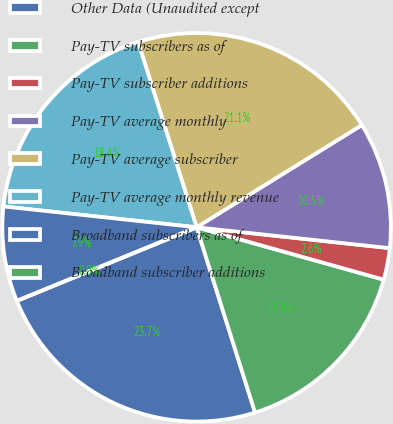<chart> <loc_0><loc_0><loc_500><loc_500><pie_chart><fcel>Other Data (Unaudited except<fcel>Pay-TV subscribers as of<fcel>Pay-TV subscriber additions<fcel>Pay-TV average monthly<fcel>Pay-TV average subscriber<fcel>Pay-TV average monthly revenue<fcel>Broadband subscribers as of<fcel>Broadband subscriber additions<nl><fcel>23.68%<fcel>15.79%<fcel>2.63%<fcel>10.53%<fcel>21.05%<fcel>18.42%<fcel>7.89%<fcel>0.0%<nl></chart> 